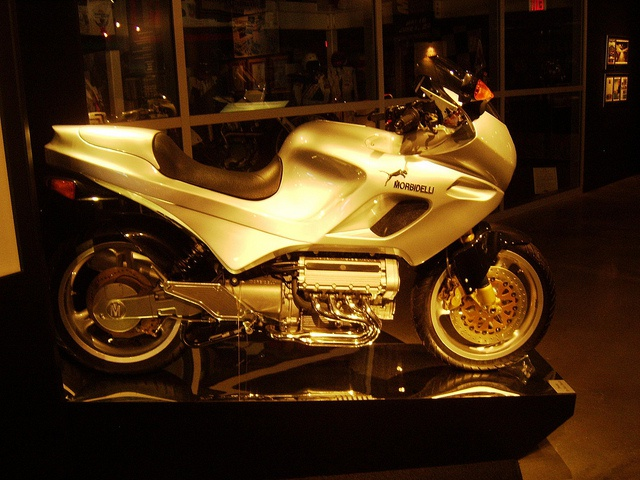Describe the objects in this image and their specific colors. I can see a motorcycle in black, maroon, olive, and orange tones in this image. 